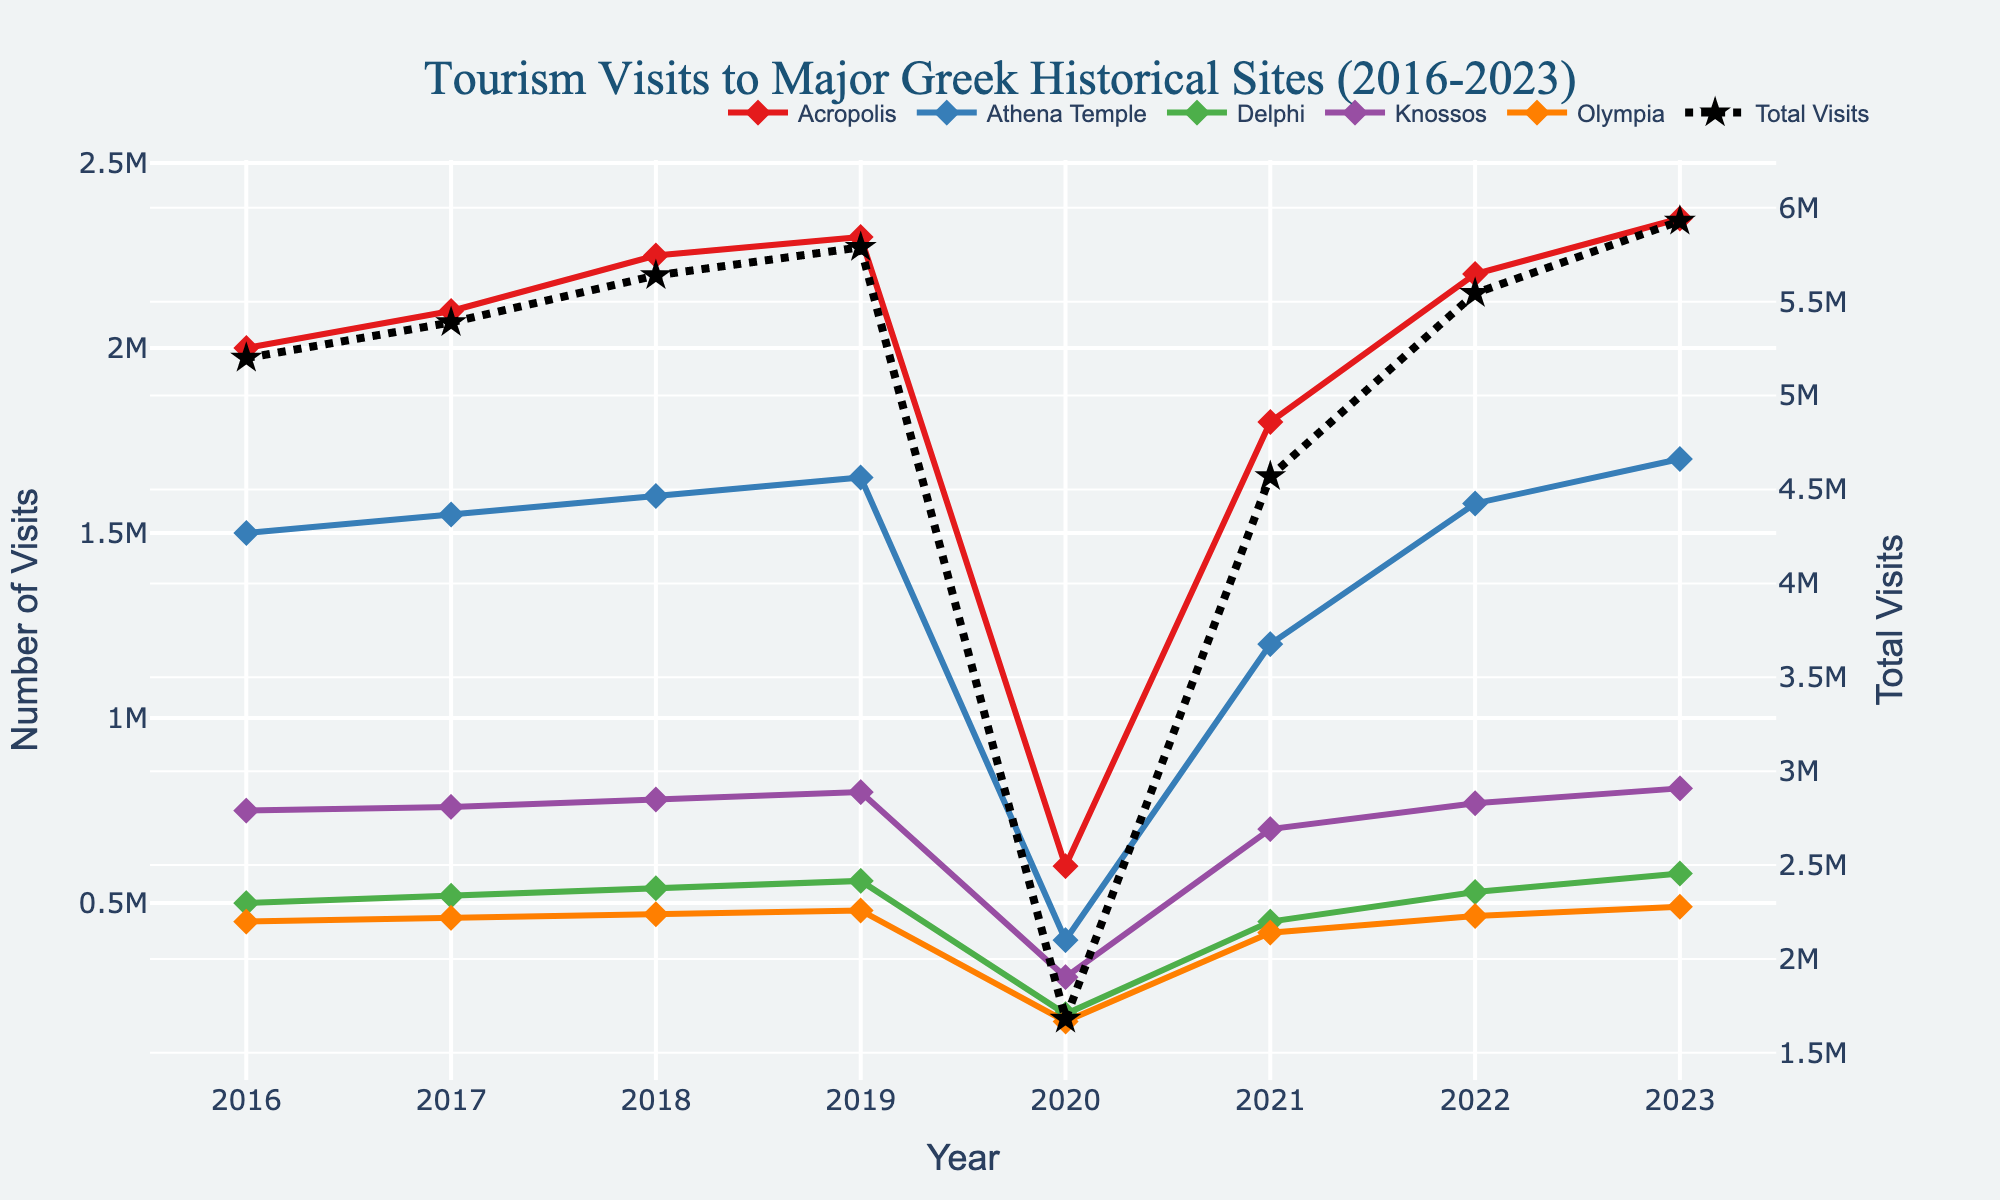What is the title of the plot? Look at the top of the plot where the title is displayed. It reads "Tourism Visits to Major Greek Historical Sites (2016-2023)."
Answer: Tourism Visits to Major Greek Historical Sites (2016-2023) Which historical site had the highest number of visits in 2023? Checking the y-values for 2023, the Acropolis had the highest number of visits at 2,350,000 among all listed sites.
Answer: Acropolis By how much did the total visits decrease between 2019 and 2020? The total visits in 2019 sum to 5,900,000 and in 2020 sum to 1,480,000. The difference is 5,900,000 - 1,480,000.
Answer: 4,420,000 How many years experienced a decrease in visits to the Acropolis compared to the previous year? Examining the Acropolis' y-values per year: 2016 to 2017 increased, 2017 to 2018 increased, 2018 to 2019 increased, 2019 to 2020 decreased, 2020 to 2021 increased, 2021 to 2022 increased, 2022 to 2023 increased. Hence, there was 1 year of decrease.
Answer: 1 year Which historical site had the smallest number of visits in 2020, and what was the count? Review 2020 data for all sites: Acropolis 600,000, Athena Temple 400,000, Delphi 200,000, Knossos 300,000, Olympia 180,000. The smallest number of visits was for Olympia at 180,000.
Answer: Olympia, 180,000 What was the trend in visits to the Athena Temple from 2020 to 2023? Observing y-values for the Athena Temple: 400,000 in 2020, 1,200,000 in 2021, 1,580,000 in 2022, 1,700,000 in 2023. The visits increased every year.
Answer: Increasing Compare the number of visits to Delphi in 2016 and 2023. Which year had more visits and by how much? Comparing Delphi visits in 2016 (500,000) to 2023 (580,000). 2023 had more visits by 580,000 - 500,000.
Answer: 2023, 80,000 more What was the total number of visits to all sites in 2022? Sum the visits for 2022: Acropolis 2,200,000, Athena Temple 1,580,000, Delphi 530,000, Knossos 770,000, Olympia 465,000. Summing these gives 5,545,000.
Answer: 5,545,000 